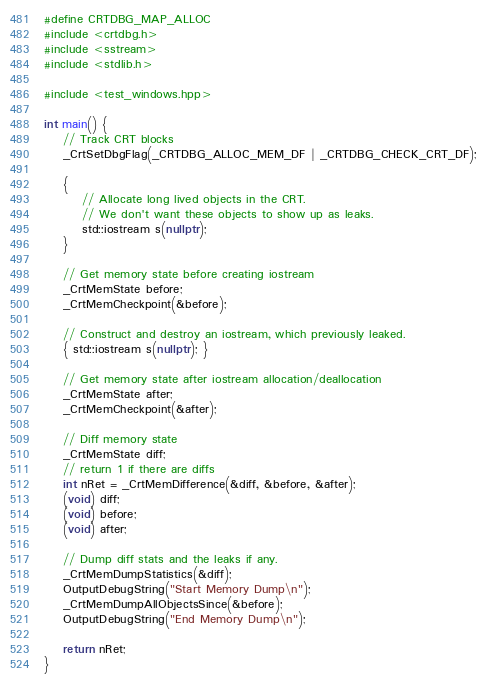<code> <loc_0><loc_0><loc_500><loc_500><_C++_>#define CRTDBG_MAP_ALLOC
#include <crtdbg.h>
#include <sstream>
#include <stdlib.h>

#include <test_windows.hpp>

int main() {
    // Track CRT blocks
    _CrtSetDbgFlag(_CRTDBG_ALLOC_MEM_DF | _CRTDBG_CHECK_CRT_DF);

    {
        // Allocate long lived objects in the CRT.
        // We don't want these objects to show up as leaks.
        std::iostream s(nullptr);
    }

    // Get memory state before creating iostream
    _CrtMemState before;
    _CrtMemCheckpoint(&before);

    // Construct and destroy an iostream, which previously leaked.
    { std::iostream s(nullptr); }

    // Get memory state after iostream allocation/deallocation
    _CrtMemState after;
    _CrtMemCheckpoint(&after);

    // Diff memory state
    _CrtMemState diff;
    // return 1 if there are diffs
    int nRet = _CrtMemDifference(&diff, &before, &after);
    (void) diff;
    (void) before;
    (void) after;

    // Dump diff stats and the leaks if any.
    _CrtMemDumpStatistics(&diff);
    OutputDebugString("Start Memory Dump\n");
    _CrtMemDumpAllObjectsSince(&before);
    OutputDebugString("End Memory Dump\n");

    return nRet;
}
</code> 